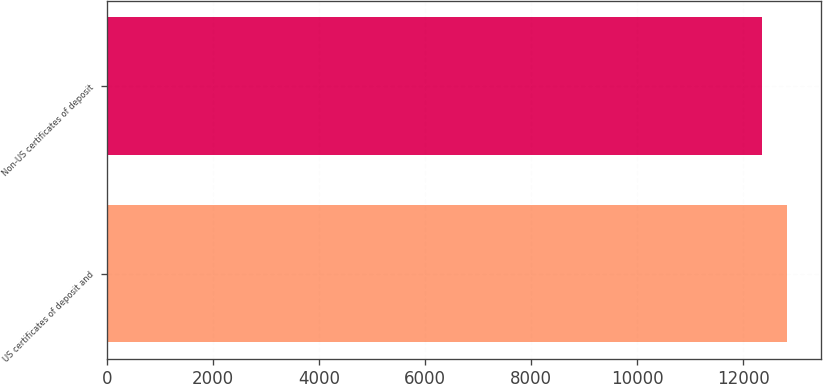<chart> <loc_0><loc_0><loc_500><loc_500><bar_chart><fcel>US certificates of deposit and<fcel>Non-US certificates of deposit<nl><fcel>12836<fcel>12352<nl></chart> 